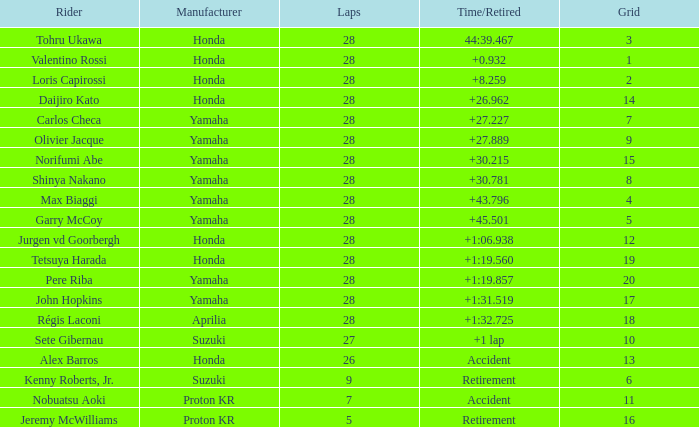How many times did pere riba circle the track? 28.0. 